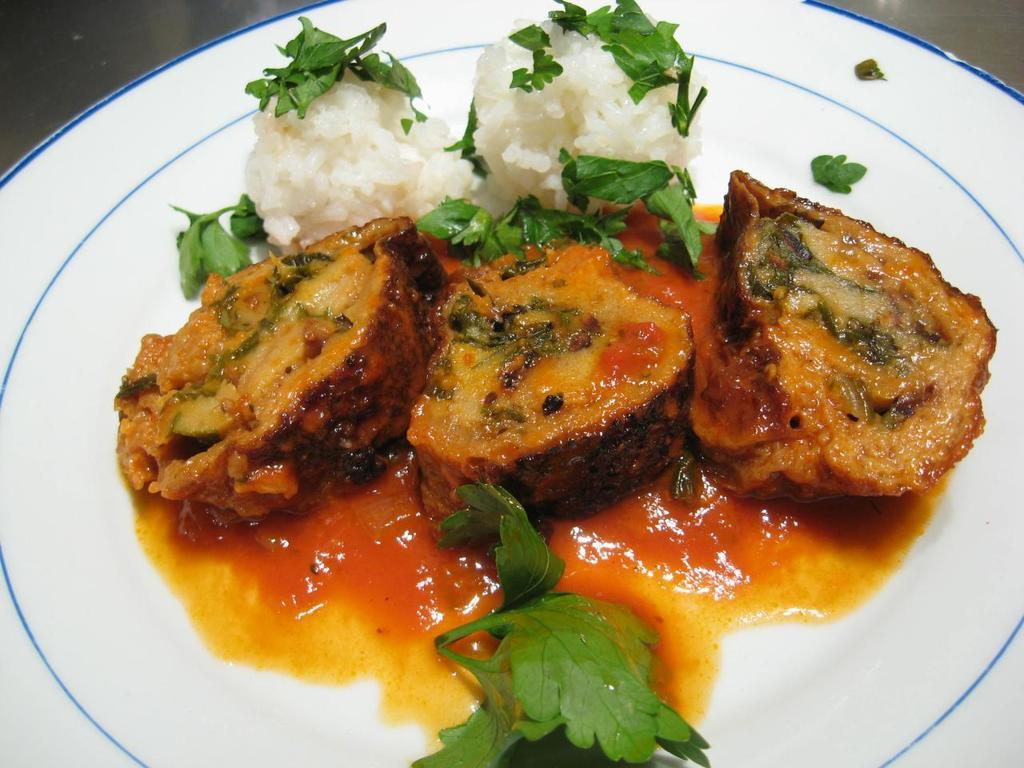What types of items are present in the image? There are food items and green color leaves in the image. What color are the leaves in the image? The leaves in the image are green in color. On what object are the food items and leaves placed? The food items and leaves are on a white color plate. How many horses can be seen grazing on the ground in the image? There are no horses or ground visible in the image; it features food items and leaves on a white color plate. 